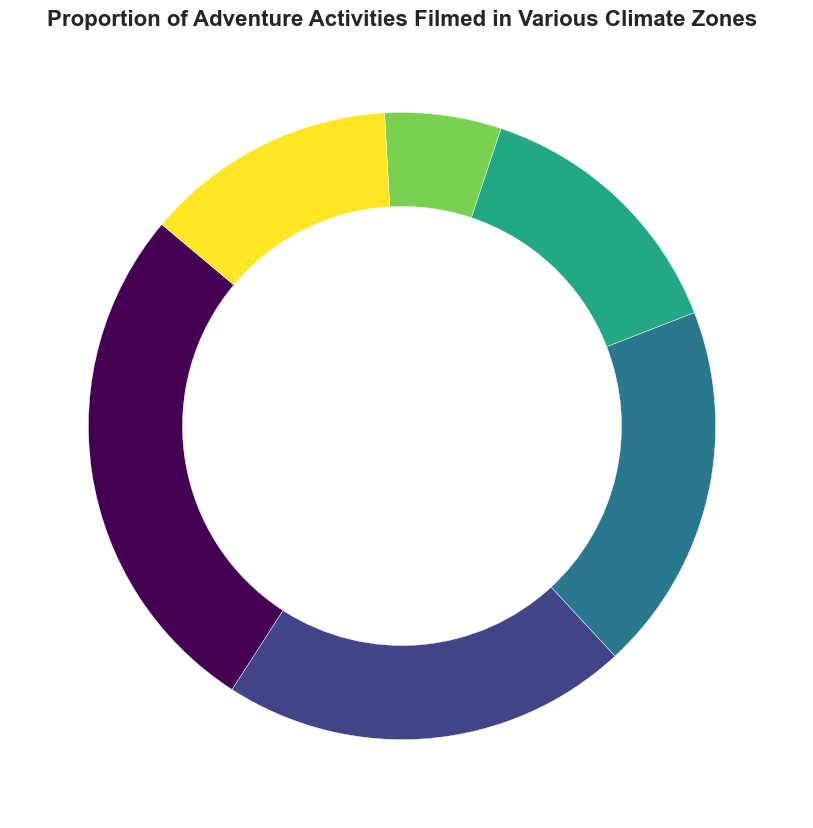Which climate zone has the highest proportion of adventure activities filmed? Locate the wedge representing the largest proportion in the pie chart. The label "Tropical" corresponds to the largest wedge at 27%.
Answer: Tropical Which climate zone has the lowest proportion and what is its percentage? Find the smallest wedge in the pie chart. The "Polar" climate zone is the smallest, indicated by 6%.
Answer: Polar, 6% What is the combined proportion of adventure activities filmed in Temperate and Continental climate zones? Add the proportions of Temperate (19%) and Continental (14%), which equals 19 + 14.
Answer: 33% Is the proportion of activities filmed in Dry climate zones higher or lower than those filmed in Highland climate zones? Compare the proportions: Dry is 21% and Highland is 13%. Since 21 is greater than 13, activities in Dry zones are higher.
Answer: Higher What is the average proportion of adventure activities filmed in Tropical, Temperate, and Continental climate zones? Add the proportions of Tropical (27%), Temperate (19%), and Continental (14%). Then divide by 3: (27 + 19 + 14)/3 = 20.
Answer: 20% Do Tropical and Dry climate zones together account for more than 50% of the adventure activities? Add the proportions of Tropical (27%) and Dry (21%). The sum is 27 + 21 = 48%, which is less than 50%.
Answer: No Which three climate zones combined have the majority (more than 50%) of filmed adventure activities? Sum the top three largest proportions: Tropical (27%), Dry (21%), and Temperate (19%): 27 + 21 + 19 = 67%, which is more than 50%.
Answer: Tropical, Dry, Temperate What is the difference in proportion between the Tropical and Polar climate zones? Subtract the proportion of Polar (6%) from Tropical (27%): 27 - 6 = 21%.
Answer: 21% Are there any climate zones with an equal proportion of adventure activities filmed? Observe the wedges for any equal-sized segments. No climate zones have matching percentages.
Answer: No What is the total proportion of adventure activities filmed in zones other than Tropical? Add the proportions of Dry (21%), Temperate (19%), Continental (14%), Polar (6%), and Highland (13%): 21 + 19 + 14 + 6 + 13 = 73%.
Answer: 73% 